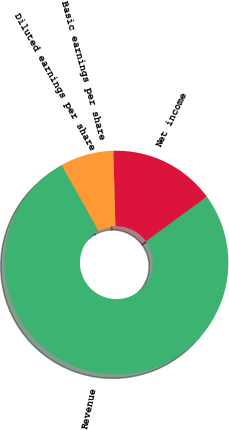<chart> <loc_0><loc_0><loc_500><loc_500><pie_chart><fcel>Revenue<fcel>Net income<fcel>Basic earnings per share<fcel>Diluted earnings per share<nl><fcel>76.91%<fcel>15.39%<fcel>7.7%<fcel>0.01%<nl></chart> 